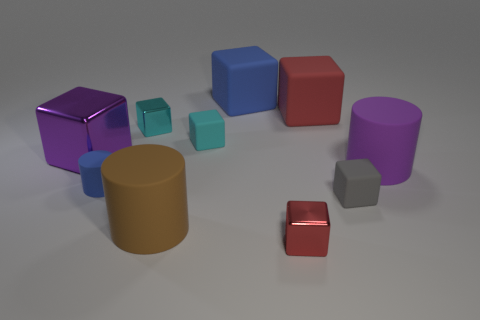Subtract all large matte cylinders. How many cylinders are left? 1 Subtract all brown cylinders. How many red blocks are left? 2 Subtract all cyan blocks. How many blocks are left? 5 Subtract 1 cylinders. How many cylinders are left? 2 Subtract all cyan cubes. Subtract all brown cylinders. How many cubes are left? 5 Subtract 0 cyan cylinders. How many objects are left? 10 Subtract all blocks. How many objects are left? 3 Subtract all cyan rubber blocks. Subtract all tiny cyan metal blocks. How many objects are left? 8 Add 5 tiny blue matte objects. How many tiny blue matte objects are left? 6 Add 2 purple metal blocks. How many purple metal blocks exist? 3 